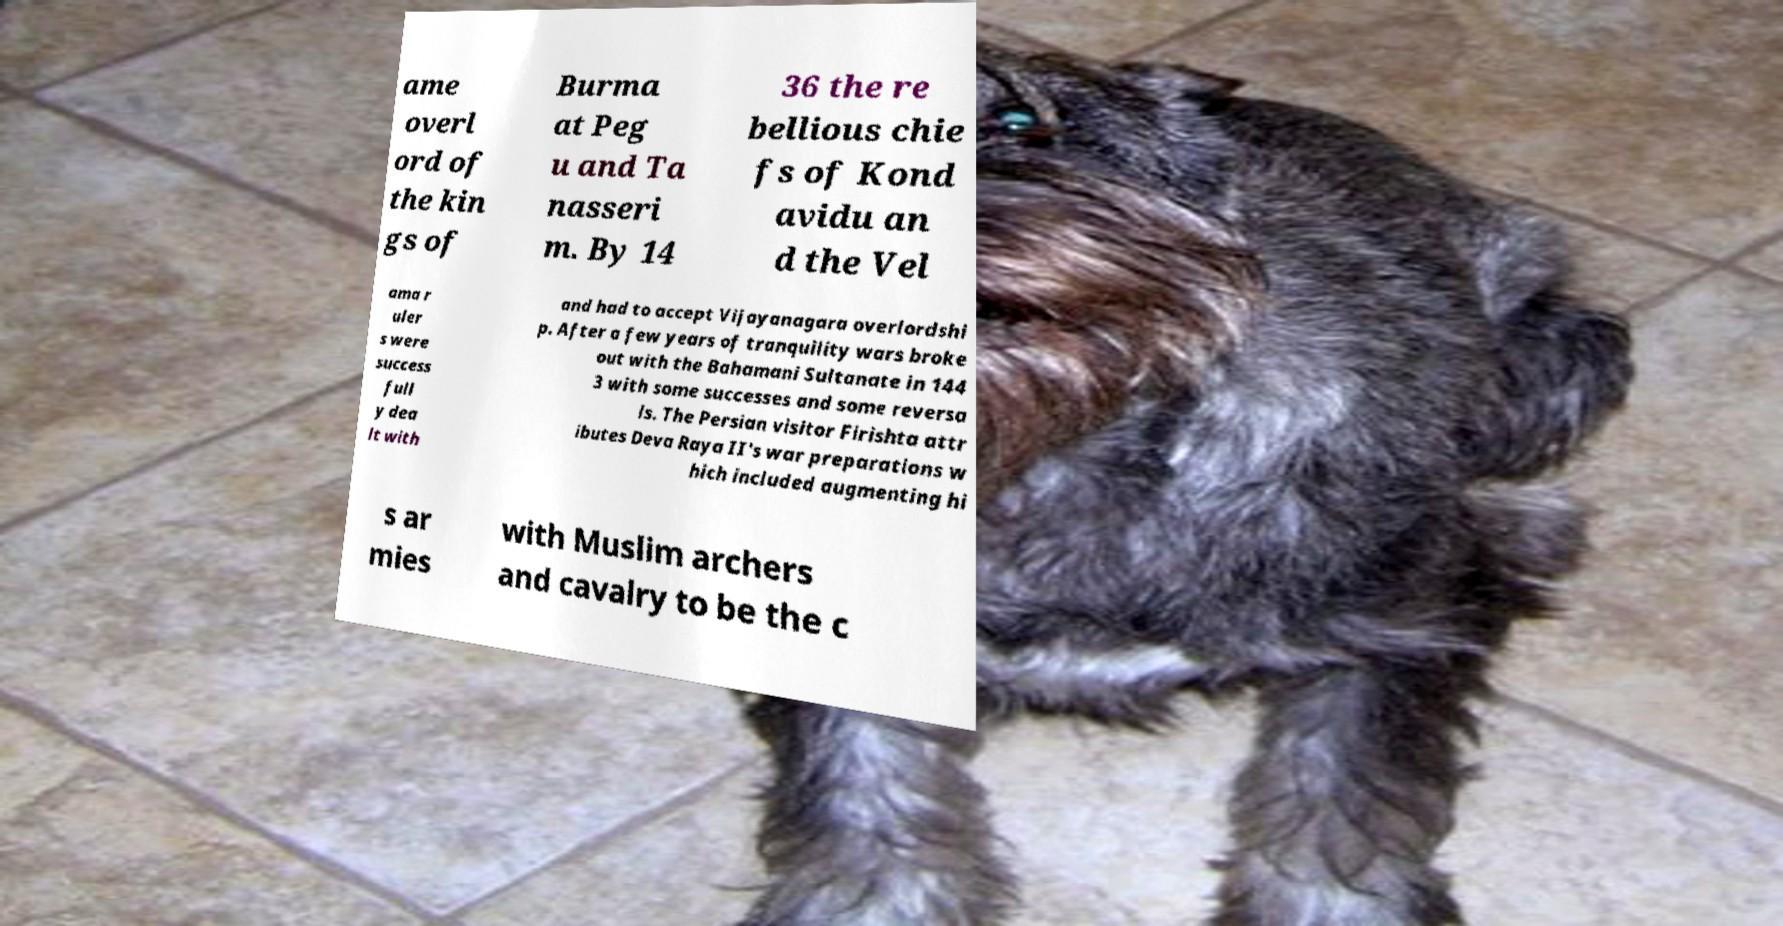For documentation purposes, I need the text within this image transcribed. Could you provide that? ame overl ord of the kin gs of Burma at Peg u and Ta nasseri m. By 14 36 the re bellious chie fs of Kond avidu an d the Vel ama r uler s were success full y dea lt with and had to accept Vijayanagara overlordshi p. After a few years of tranquility wars broke out with the Bahamani Sultanate in 144 3 with some successes and some reversa ls. The Persian visitor Firishta attr ibutes Deva Raya II's war preparations w hich included augmenting hi s ar mies with Muslim archers and cavalry to be the c 